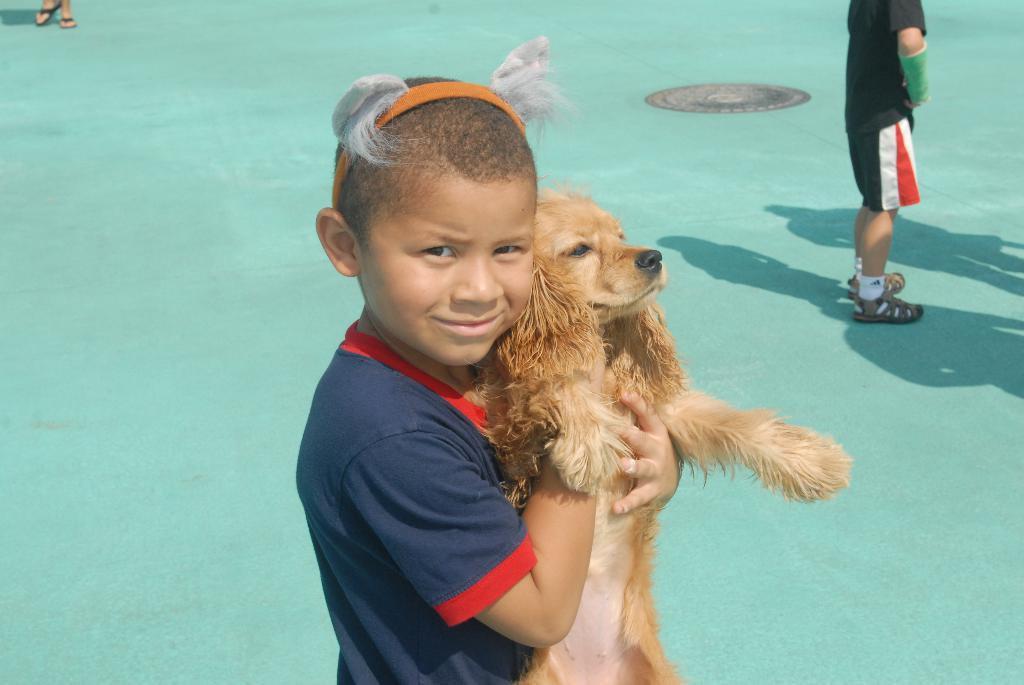What is the person in the image holding? The person is holding a dog in the image. Can you describe the person's outfit? The person is wearing a blue and red dress. What color is the dog in the image? The dog is in brown color. Is there anyone else in the image besides the person holding the dog? Yes, there is a person standing in the background of the image. What color is the floor in the image? The floor is in green color. What type of coal is being used to fuel the train in the image? There is no train present in the image, so it is not possible to determine what type of coal is being used to fuel it. 